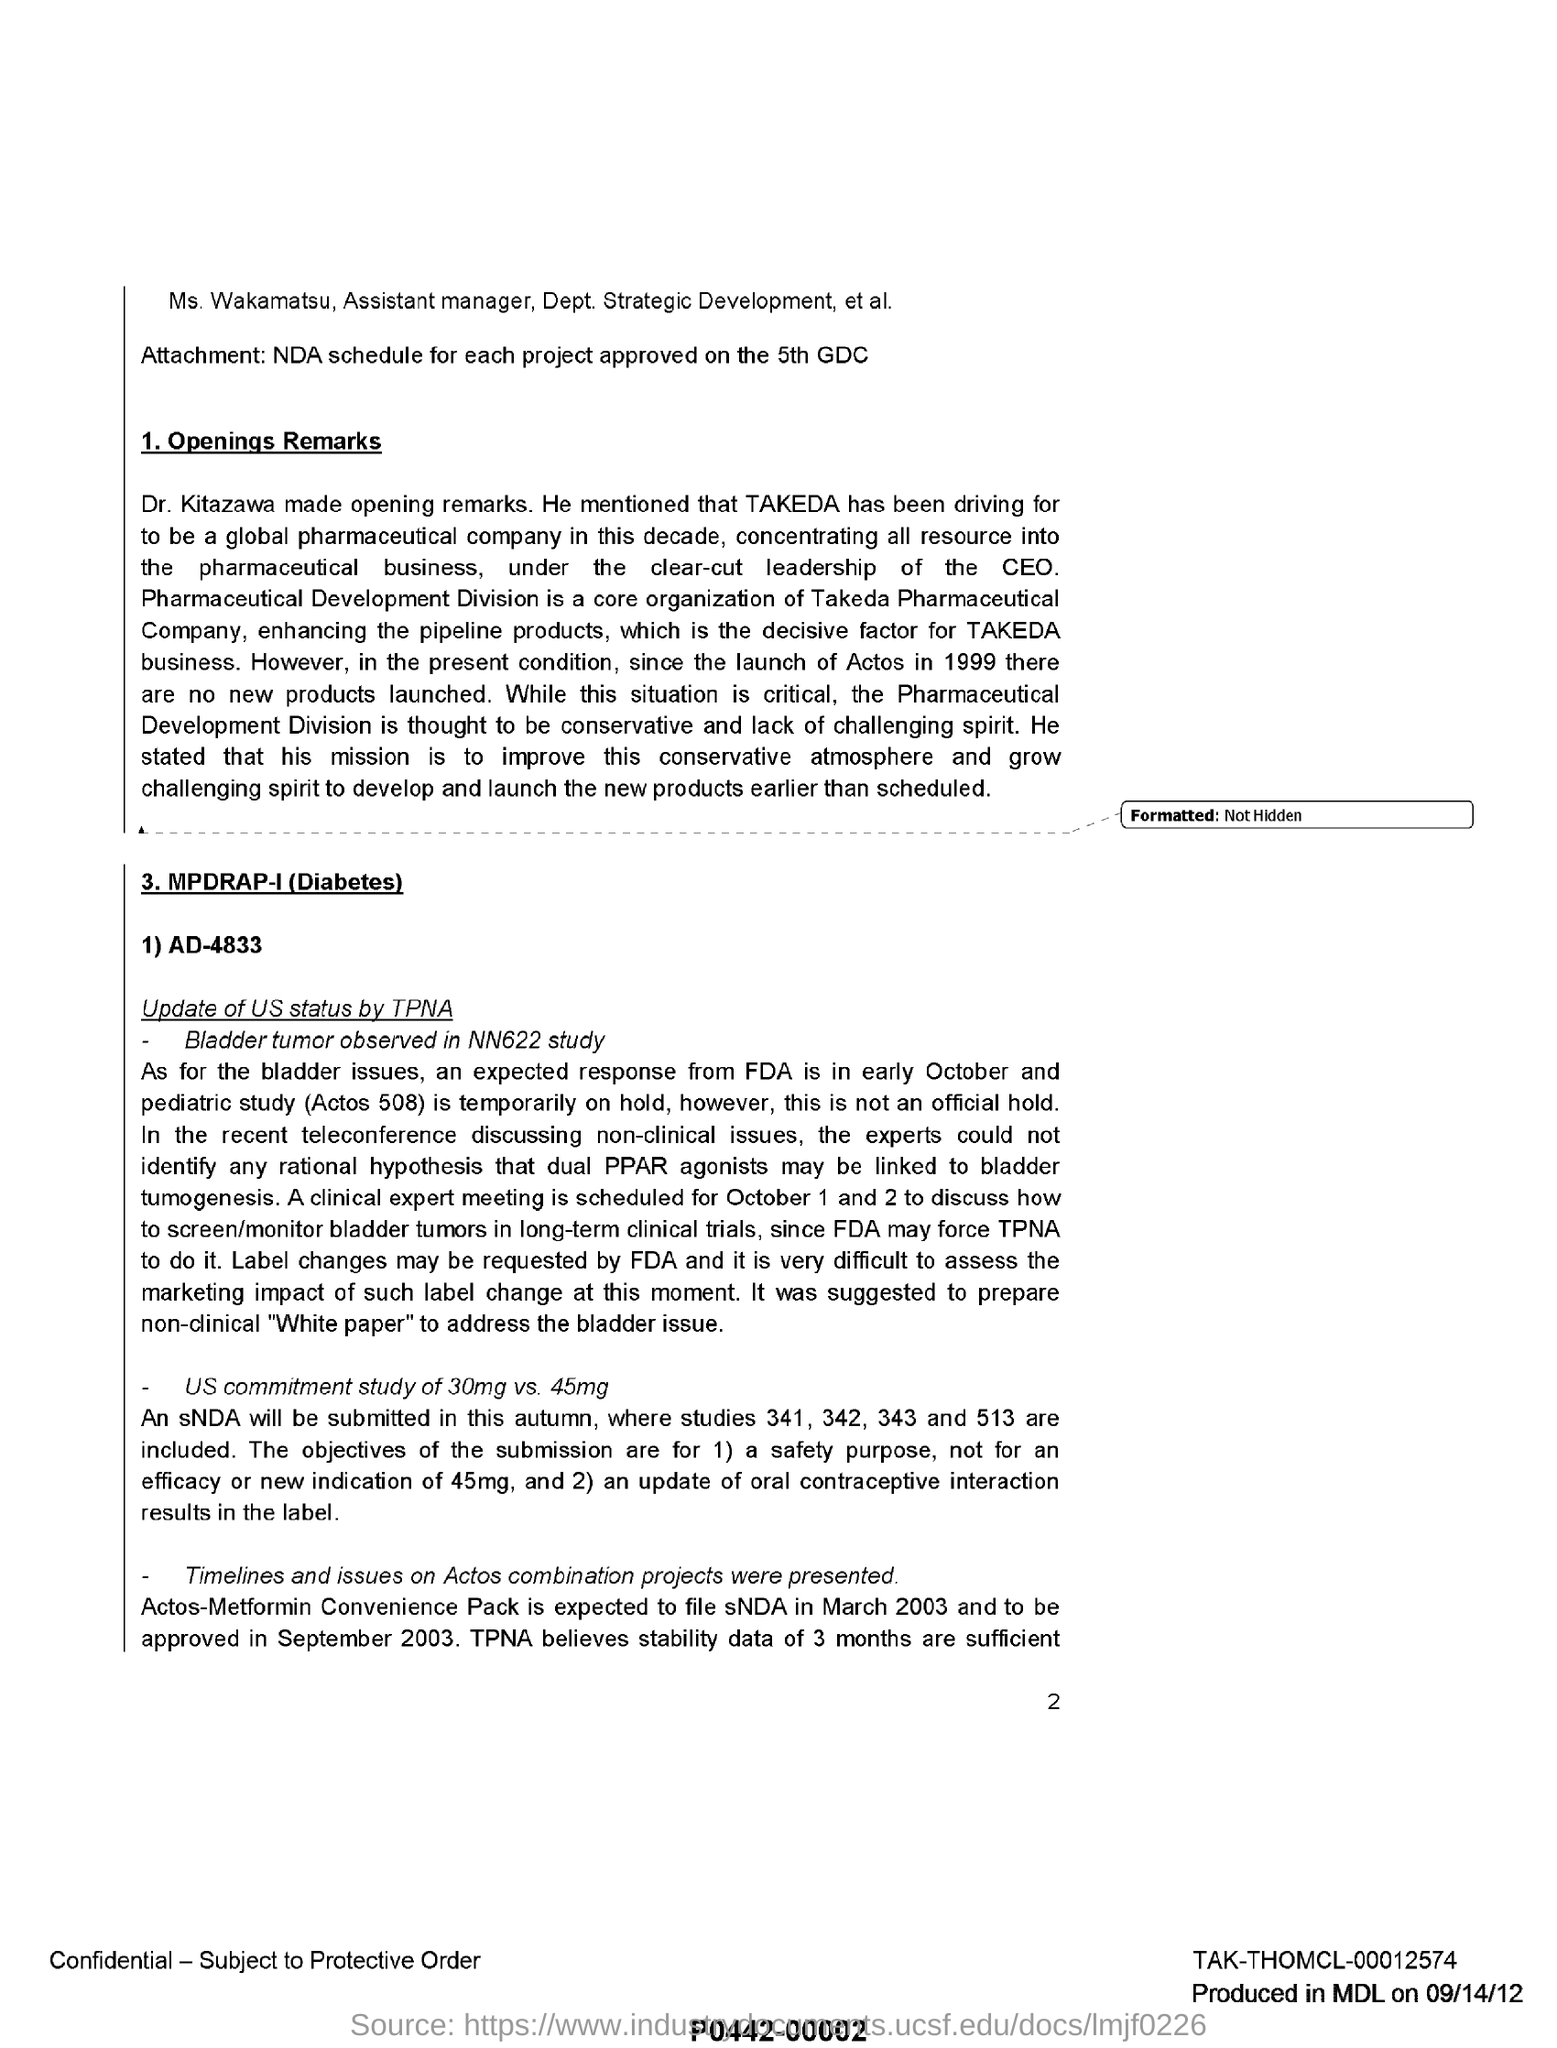Indicate a few pertinent items in this graphic. The clinical expert meeting is scheduled for October 1 and 2. It was suggested to prepare a non-clinical "white paper" in order to address the bladder issue. The speaker who made the opening remarks was Dr. Kitazawa. Takeda Pharmaceutical Company is organized around the Pharmaceutical Development Division as its core. Ms. Wakamatsu's role in the Department of Strategic Development is that of an Assistant Manager. 